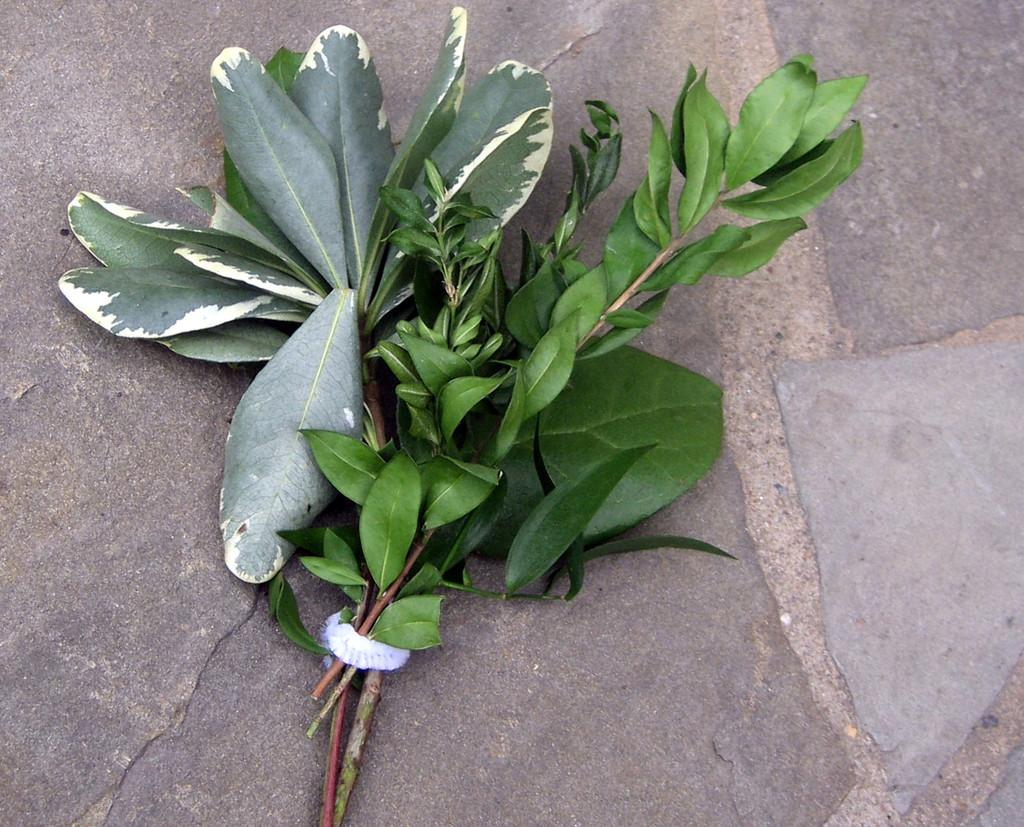How many plants are visible in the image? There are two plants in the image. What is used to tie the plants together? The plants are tied with a white object. Where are the plants located? The plants are on the ground. What type of birds can be seen perched on the rail in the image? There is no rail or birds present in the image; it only features two plants tied with a white object. 